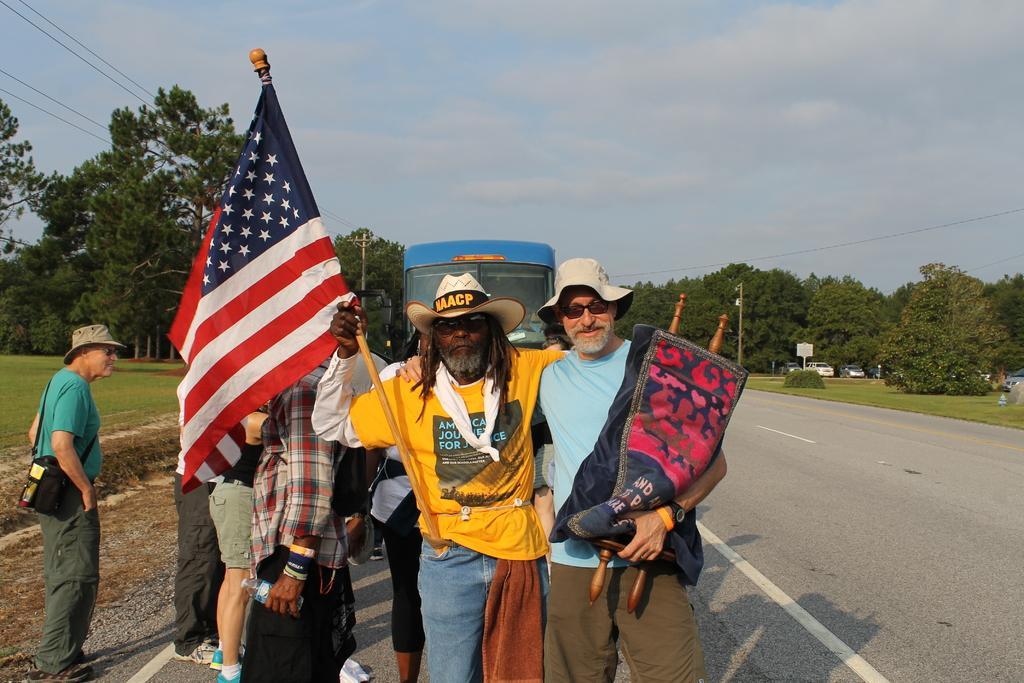Describe this image in one or two sentences. In this image we can see men are standing. One man is wearing yellow color t-shirt with jeans and holding flag in his hand. And the other man is wearing blue color t-shirt with brown pant and holding some wooden thing in his hand. Background of the image grassy land, road, cars, bus and trees are there. At the top of the image sky is covered with clouds and wires are present. 